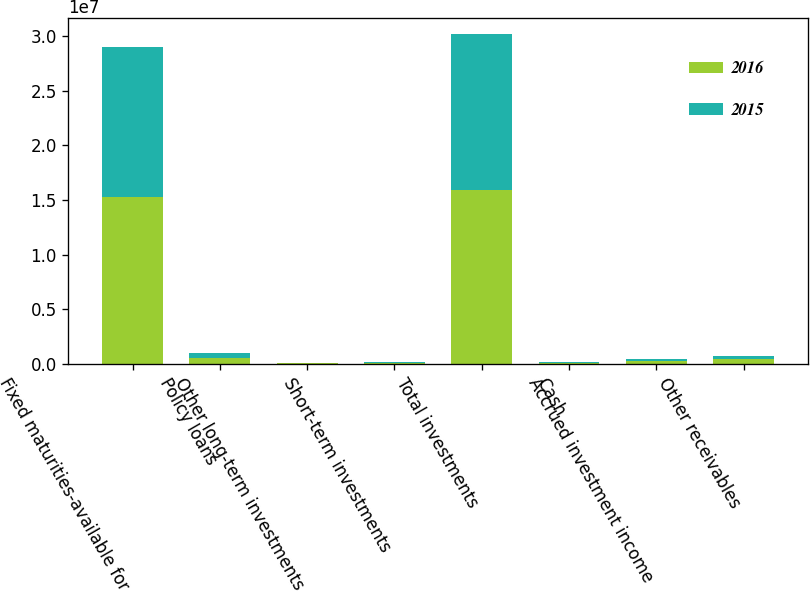Convert chart to OTSL. <chart><loc_0><loc_0><loc_500><loc_500><stacked_bar_chart><ecel><fcel>Fixed maturities-available for<fcel>Policy loans<fcel>Other long-term investments<fcel>Short-term investments<fcel>Total investments<fcel>Cash<fcel>Accrued investment income<fcel>Other receivables<nl><fcel>2016<fcel>1.52459e+07<fcel>507975<fcel>53852<fcel>72040<fcel>1.58797e+07<fcel>76163<fcel>223148<fcel>384454<nl><fcel>2015<fcel>1.3758e+07<fcel>492462<fcel>38438<fcel>54766<fcel>1.43437e+07<fcel>61383<fcel>209915<fcel>344552<nl></chart> 